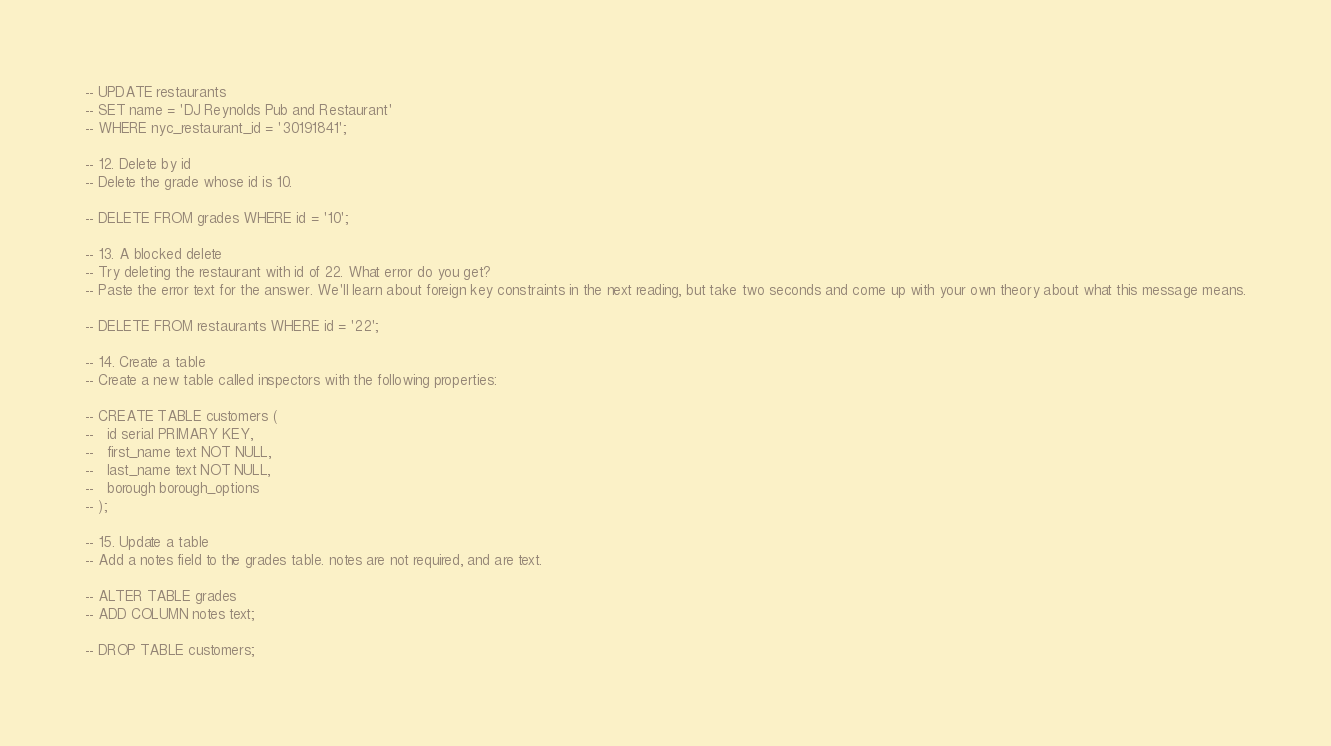<code> <loc_0><loc_0><loc_500><loc_500><_SQL_>
-- UPDATE restaurants
-- SET name = 'DJ Reynolds Pub and Restaurant'
-- WHERE nyc_restaurant_id = '30191841';

-- 12. Delete by id
-- Delete the grade whose id is 10.

-- DELETE FROM grades WHERE id = '10';

-- 13. A blocked delete
-- Try deleting the restaurant with id of 22. What error do you get?
-- Paste the error text for the answer. We'll learn about foreign key constraints in the next reading, but take two seconds and come up with your own theory about what this message means.

-- DELETE FROM restaurants WHERE id = '22';

-- 14. Create a table
-- Create a new table called inspectors with the following properties:

-- CREATE TABLE customers (
--   id serial PRIMARY KEY,
--   first_name text NOT NULL,
--   last_name text NOT NULL,
--   borough borough_options
-- );

-- 15. Update a table
-- Add a notes field to the grades table. notes are not required, and are text.

-- ALTER TABLE grades
-- ADD COLUMN notes text;

-- DROP TABLE customers;
</code> 